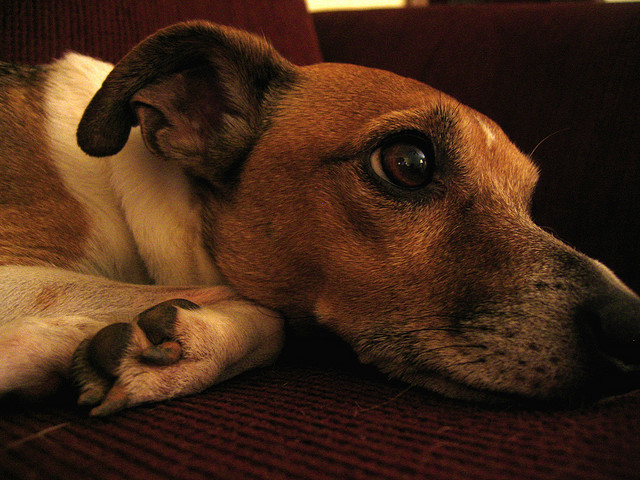<image>What is the dog looking at? I don't know what the dog is looking at. It could be looking at a variety of things like a person, food, or even just into the air. What is the dog looking at? I don't know what the dog is looking at. It can be any of the options mentioned. 